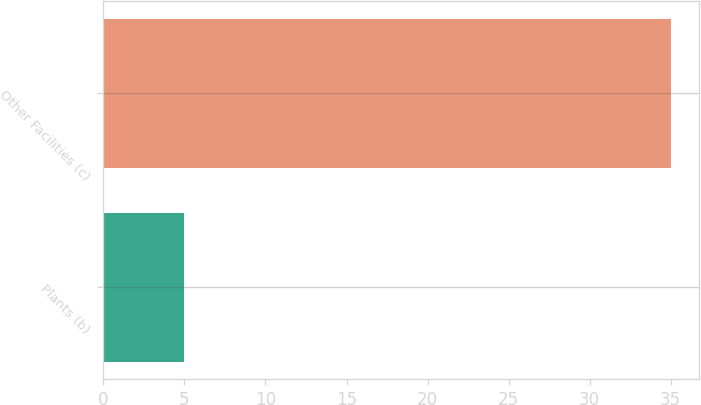<chart> <loc_0><loc_0><loc_500><loc_500><bar_chart><fcel>Plants (b)<fcel>Other Facilities (c)<nl><fcel>5<fcel>35<nl></chart> 